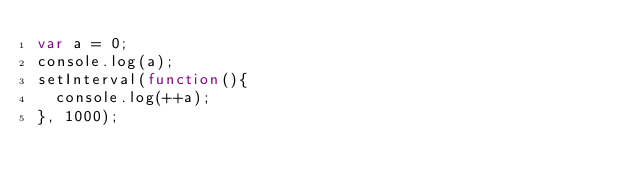<code> <loc_0><loc_0><loc_500><loc_500><_JavaScript_>var a = 0;
console.log(a);
setInterval(function(){
  console.log(++a);
}, 1000);
</code> 